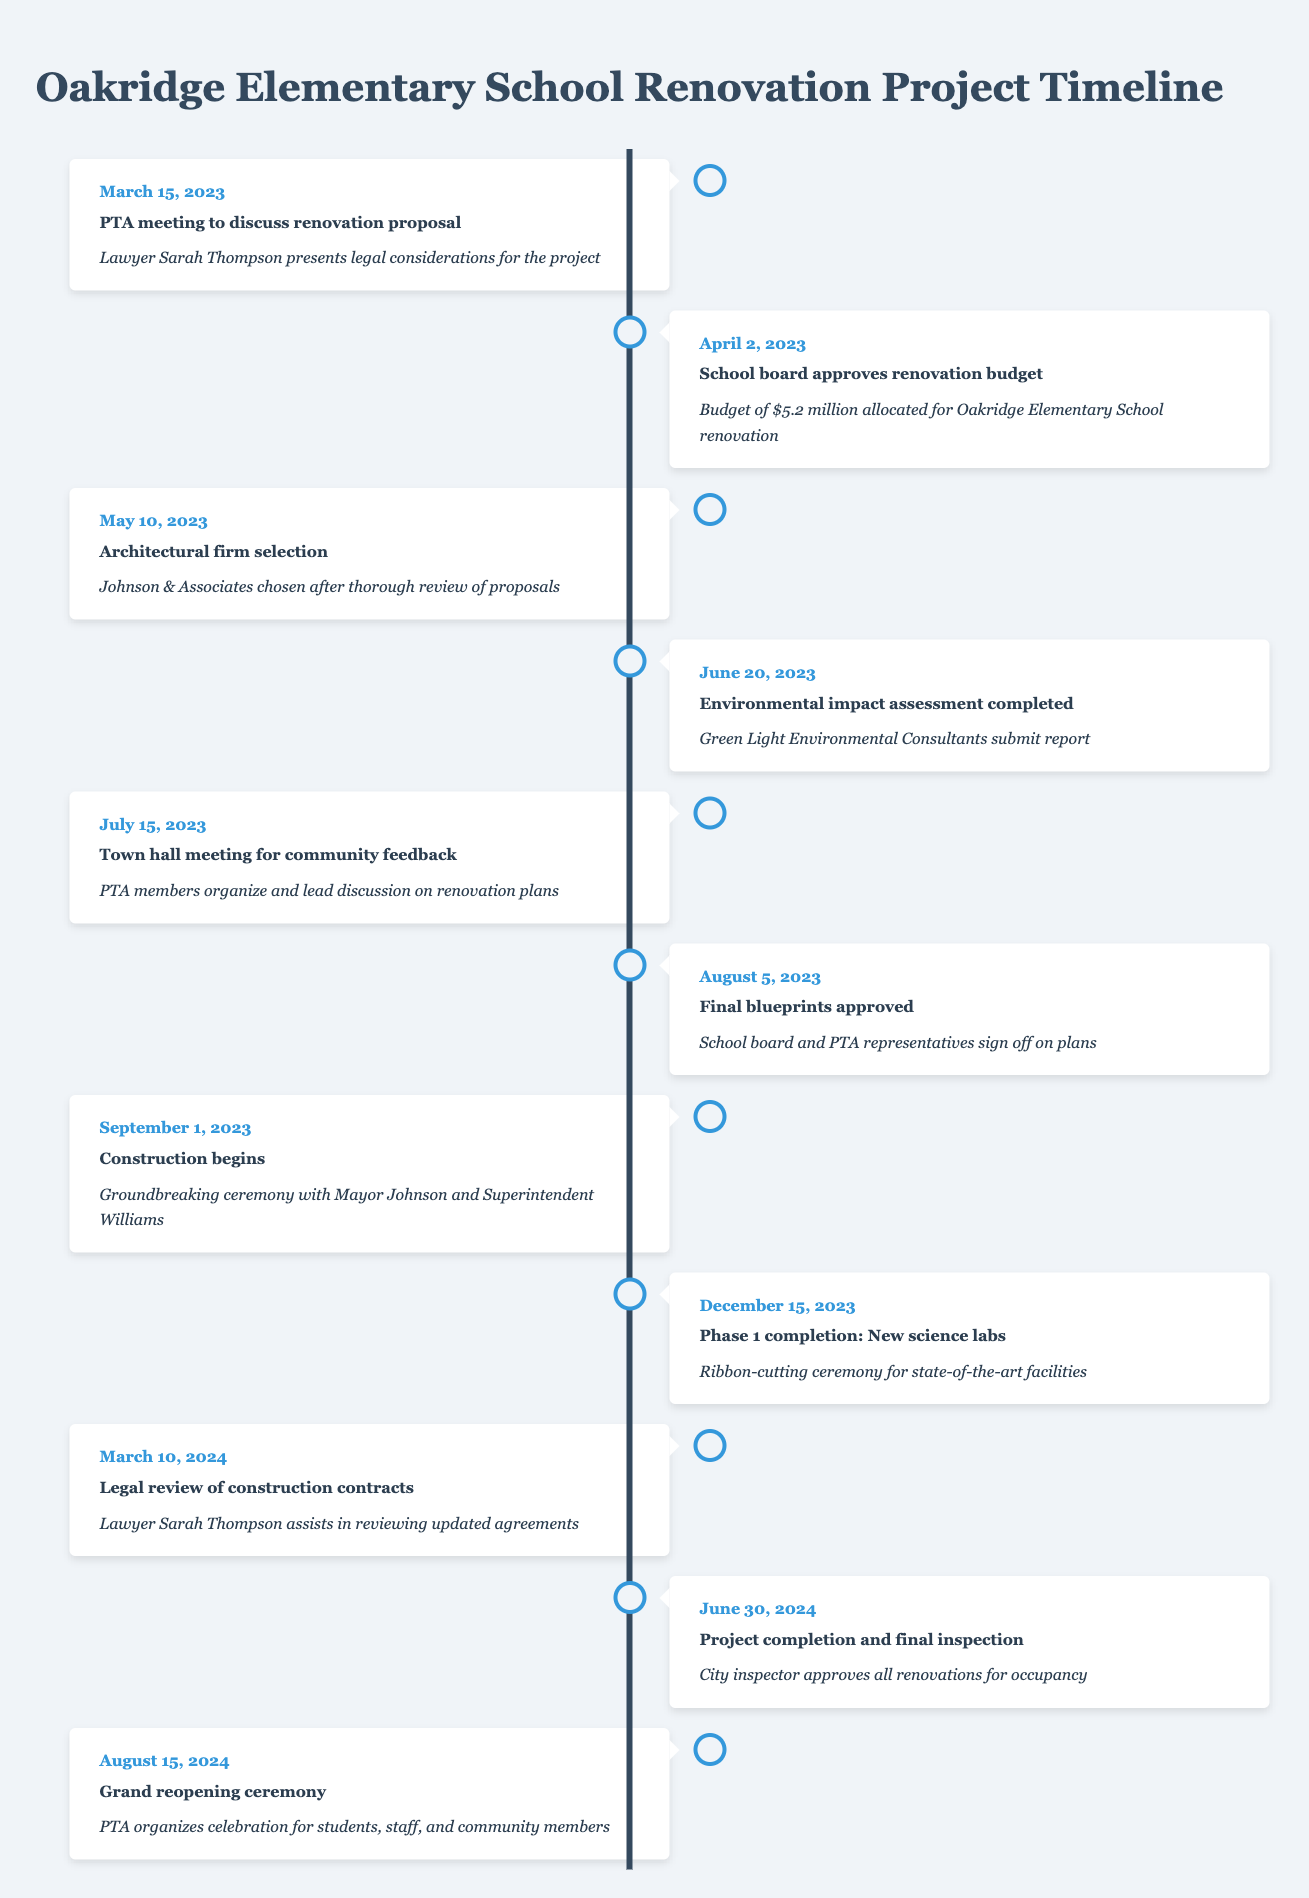What is the budget allocated for the renovation? The budget allocated is stated in the event on April 2, 2023. It mentions a budget of $5.2 million specifically for the Oakridge Elementary School renovation.
Answer: 5.2 million When was the architectural firm selected? The architectural firm was chosen on May 10, 2023, as indicated by the corresponding event, which states "Johnson & Associates chosen after thorough review of proposals."
Answer: May 10, 2023 Is the environmental impact assessment completed before construction begins? The environmental impact assessment was completed on June 20, 2023, while construction begins on September 1, 2023. Since June is before September, the assessment was completed before construction.
Answer: Yes What percentage of the timeline is dedicated to community feedback up to the start of construction? The timeline includes an event for community feedback on July 15, 2023. From the start of meetings on March 15 to construction beginning on September 1, there are 5 events (total 5 months, roughly). Thus, since community feedback is one event out of these, we can calculate the percentage as (1/5)*100 = 20%.
Answer: 20% Which event has Sarah Thompson's involvement, and when did it occur? Sarah Thompson is involved in two events: the PTA meeting on March 15, 2023, and the legal review of construction contracts on March 10, 2024. However, the involvement mentioned in the renovation context specifically refers to the first event on March 15, 2023.
Answer: PTA meeting on March 15, 2023 What is the duration between the start of construction and the completion of Phase 1? Construction starts on September 1, 2023, and Phase 1 is completed on December 15, 2023. To find the duration, we can count the months between these two dates: September to December is exactly 3.5 months (including parts of September and December).
Answer: 3.5 months Based on the timeline, when is the grand reopening ceremony scheduled? The grand reopening ceremony is scheduled for August 15, 2024, as indicated in the final entry of the timeline.
Answer: August 15, 2024 Was the final inspection done before the grand reopening ceremony? The final inspection is noted on June 30, 2024, which occurs before the grand reopening ceremony on August 15, 2024. Thus, we conclude that the inspection happened before the ceremony.
Answer: Yes What two legal events are mentioned in the timeline, and when do they occur? The timeline mentions two legal events: Firstly, the PTA meeting presentation on March 15, 2023; secondly, the legal review of construction contracts on March 10, 2024. Both events specify Sarah Thompson's involvement in the legal context.
Answer: March 15, 2023, and March 10, 2024 